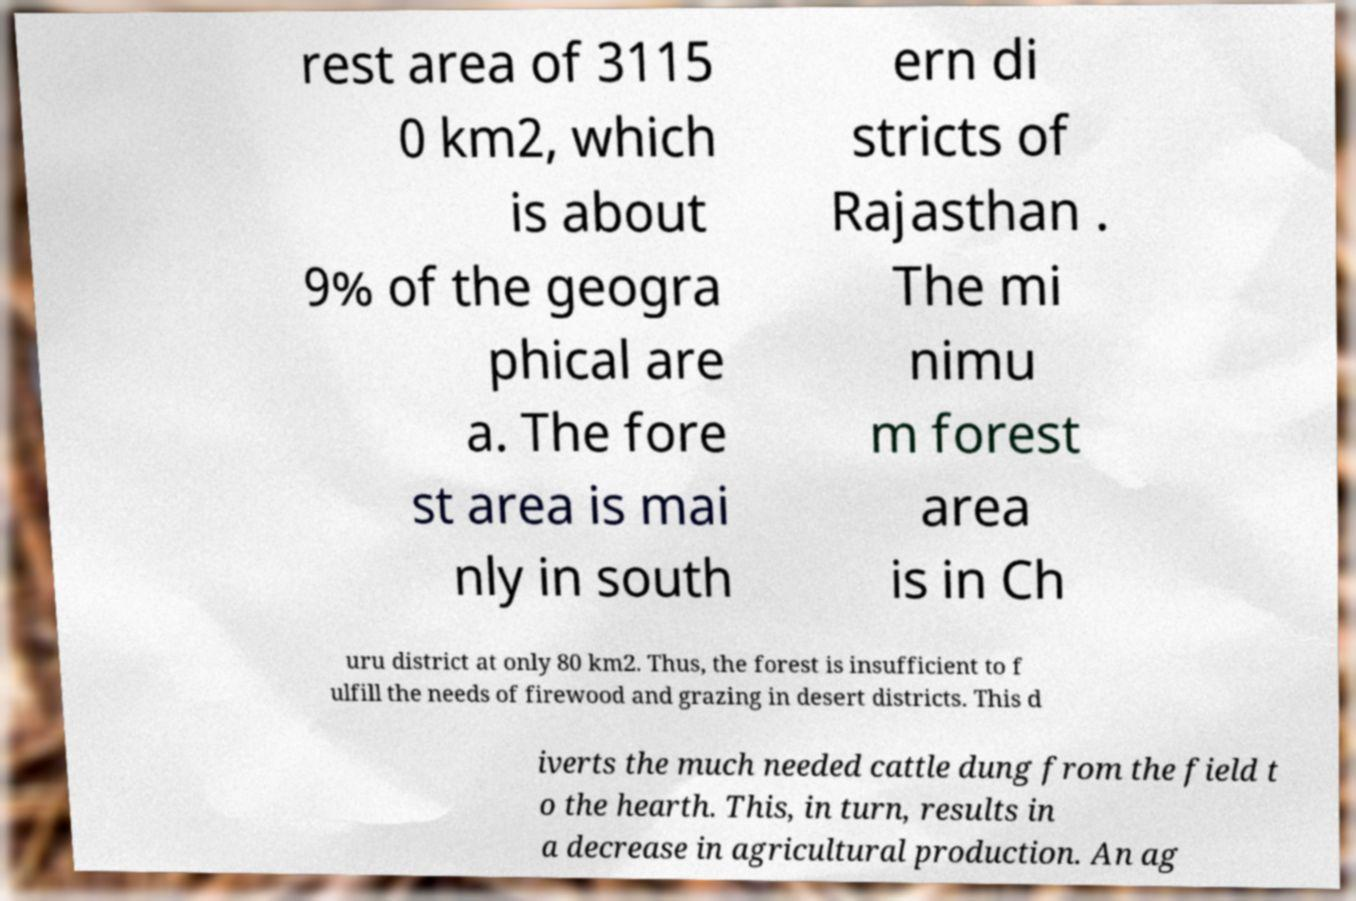For documentation purposes, I need the text within this image transcribed. Could you provide that? rest area of 3115 0 km2, which is about 9% of the geogra phical are a. The fore st area is mai nly in south ern di stricts of Rajasthan . The mi nimu m forest area is in Ch uru district at only 80 km2. Thus, the forest is insufficient to f ulfill the needs of firewood and grazing in desert districts. This d iverts the much needed cattle dung from the field t o the hearth. This, in turn, results in a decrease in agricultural production. An ag 